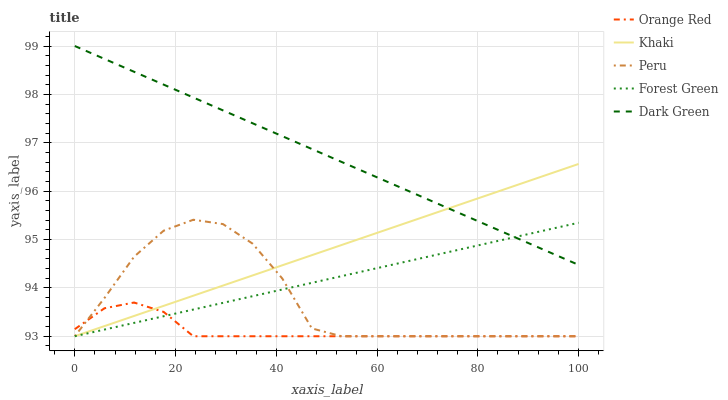Does Orange Red have the minimum area under the curve?
Answer yes or no. Yes. Does Dark Green have the maximum area under the curve?
Answer yes or no. Yes. Does Khaki have the minimum area under the curve?
Answer yes or no. No. Does Khaki have the maximum area under the curve?
Answer yes or no. No. Is Dark Green the smoothest?
Answer yes or no. Yes. Is Peru the roughest?
Answer yes or no. Yes. Is Khaki the smoothest?
Answer yes or no. No. Is Khaki the roughest?
Answer yes or no. No. Does Forest Green have the lowest value?
Answer yes or no. Yes. Does Dark Green have the lowest value?
Answer yes or no. No. Does Dark Green have the highest value?
Answer yes or no. Yes. Does Khaki have the highest value?
Answer yes or no. No. Is Orange Red less than Dark Green?
Answer yes or no. Yes. Is Dark Green greater than Peru?
Answer yes or no. Yes. Does Khaki intersect Orange Red?
Answer yes or no. Yes. Is Khaki less than Orange Red?
Answer yes or no. No. Is Khaki greater than Orange Red?
Answer yes or no. No. Does Orange Red intersect Dark Green?
Answer yes or no. No. 